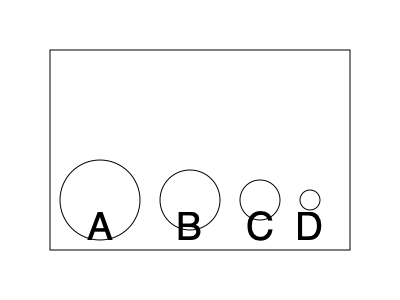In our village storage shed, we need to arrange clay pots of different sizes to save space. The diagram shows four pots (A, B, C, and D) of decreasing sizes. If we stack them from largest to smallest, how many different ways can we arrange these pots vertically? Let's approach this step-by-step:

1. We have 4 pots of different sizes, which means each pot has a unique position in the stack.

2. For the bottom (first) position:
   - We must use the largest pot (A) as the base.
   - There is only 1 choice for the first position.

3. For the second position:
   - We can use any of the remaining 3 pots (B, C, or D).
   - We have 3 choices for the second position.

4. For the third position:
   - We can use either of the 2 remaining pots.
   - We have 2 choices for the third position.

5. For the top (fourth) position:
   - We must use the smallest remaining pot.
   - There is only 1 choice for the fourth position.

6. To calculate the total number of arrangements, we multiply the number of choices for each position:
   $1 \times 3 \times 2 \times 1 = 6$

This is equivalent to calculating $4!$ (4 factorial), which represents the number of ways to arrange 4 distinct objects.

Therefore, there are 6 different ways to arrange these pots vertically from largest to smallest.
Answer: 6 ways 